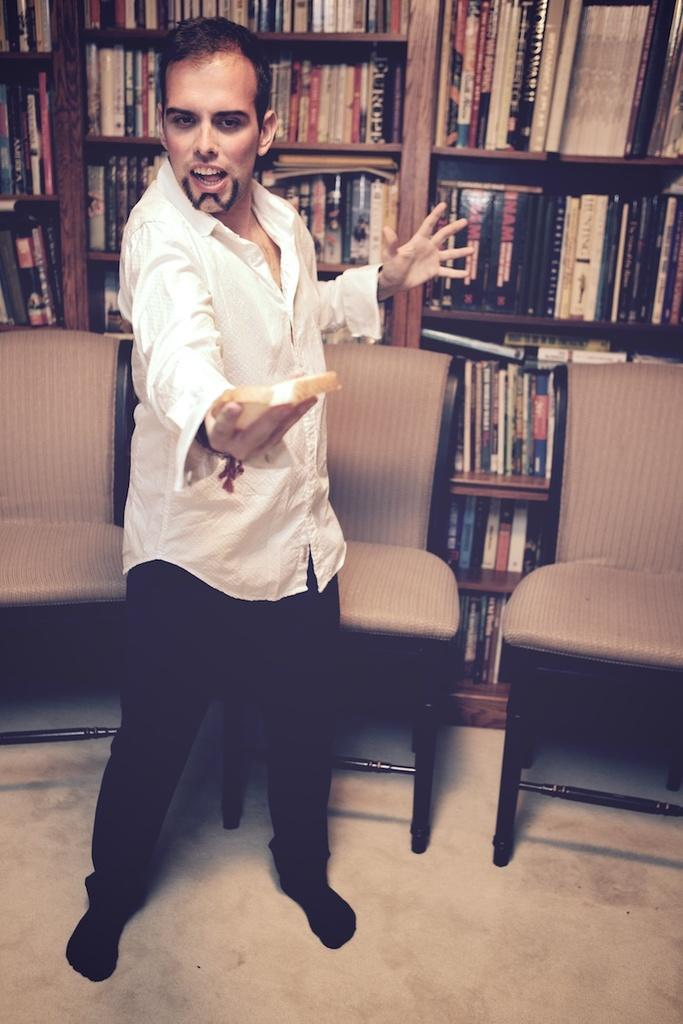What can be seen in the image? There is a person in the image. What is the person wearing? The person is wearing a white shirt. Where is the person located in the image? The person is standing on the floor. What can be seen in the background of the image? There are chairs and books on shelves in the background of the image. Can you tell me how many goats are in the image? There are no goats present in the image. What type of approval does the person in the image need to receive? There is no indication in the image that the person needs any approval. 